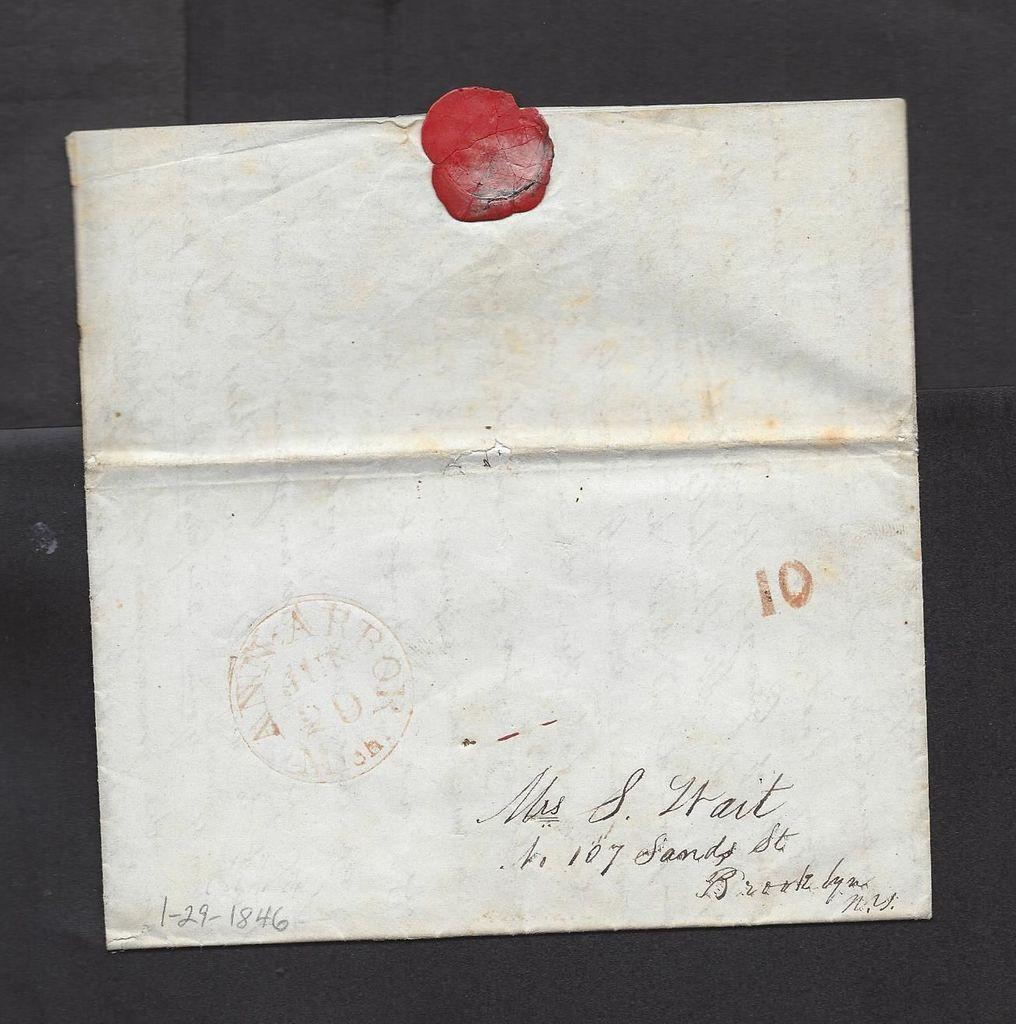<image>
Write a terse but informative summary of the picture. an old envelope with a wax seal addressed to Mrs S Wait 